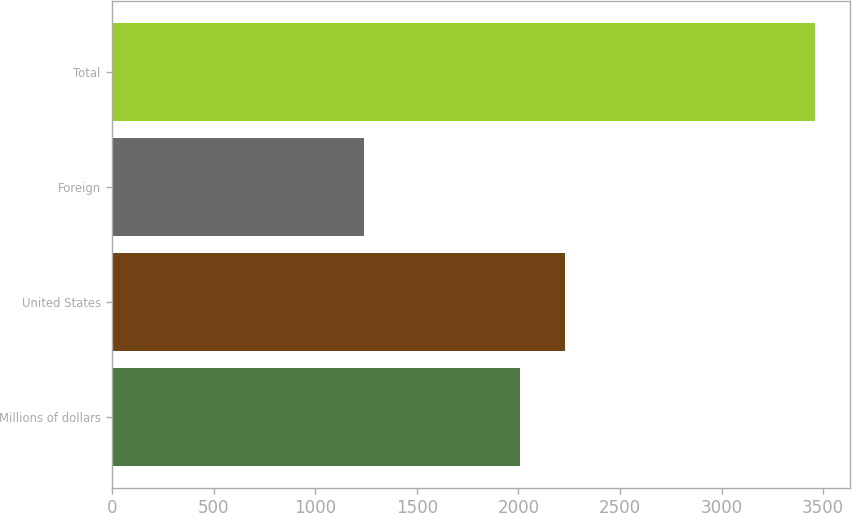Convert chart to OTSL. <chart><loc_0><loc_0><loc_500><loc_500><bar_chart><fcel>Millions of dollars<fcel>United States<fcel>Foreign<fcel>Total<nl><fcel>2007<fcel>2228.9<fcel>1241<fcel>3460<nl></chart> 